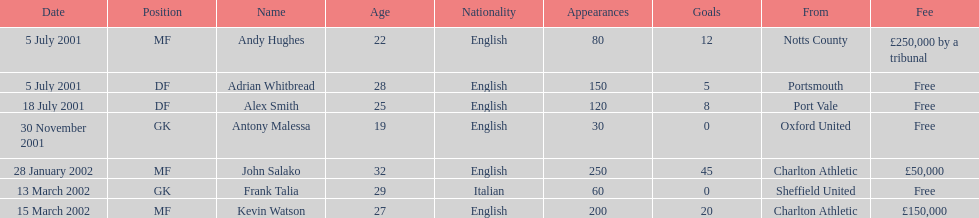Could you help me parse every detail presented in this table? {'header': ['Date', 'Position', 'Name', 'Age', 'Nationality', 'Appearances', 'Goals', 'From', 'Fee'], 'rows': [['5 July 2001', 'MF', 'Andy Hughes', '22', 'English', '80', '12', 'Notts County', '£250,000 by a tribunal'], ['5 July 2001', 'DF', 'Adrian Whitbread', '28', 'English', '150', '5', 'Portsmouth', 'Free'], ['18 July 2001', 'DF', 'Alex Smith', '25', 'English', '120', '8', 'Port Vale', 'Free'], ['30 November 2001', 'GK', 'Antony Malessa', '19', 'English', '30', '0', 'Oxford United', 'Free'], ['28 January 2002', 'MF', 'John Salako', '32', 'English', '250', '45', 'Charlton Athletic', '£50,000'], ['13 March 2002', 'GK', 'Frank Talia', '29', 'Italian', '60', '0', 'Sheffield United', 'Free'], ['15 March 2002', 'MF', 'Kevin Watson', '27', 'English', '200', '20', 'Charlton Athletic', '£150,000']]} Who transferred after 30 november 2001? John Salako, Frank Talia, Kevin Watson. 